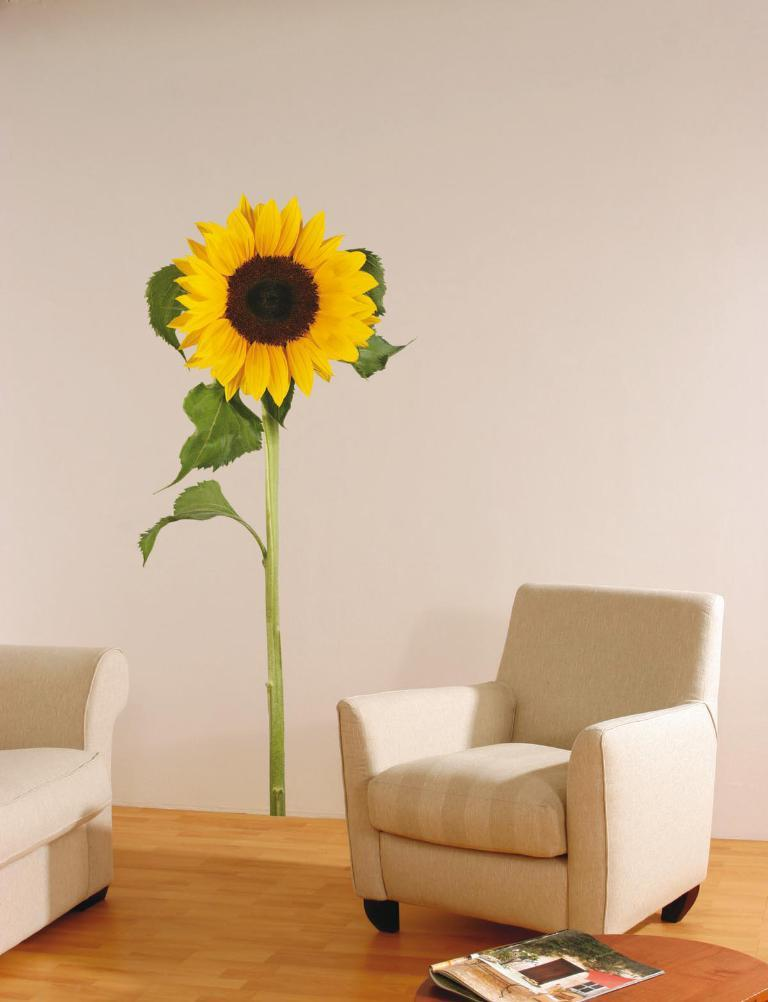What type of space is depicted in the image? The image is of a room. What decorative element can be seen on the wall in the room? There is a sunflower wall poster in the room. What type of furniture is present in the room? There are chairs in the room. What can be found on the table in the room? There is a book on a table in the room. What material is the floor made of in the room? The floor is made of wood. What type of pipe is visible in the room? There is no pipe present in the room; the image only shows a room with a sunflower wall poster, chairs, a book on a table, and a wooden floor. 